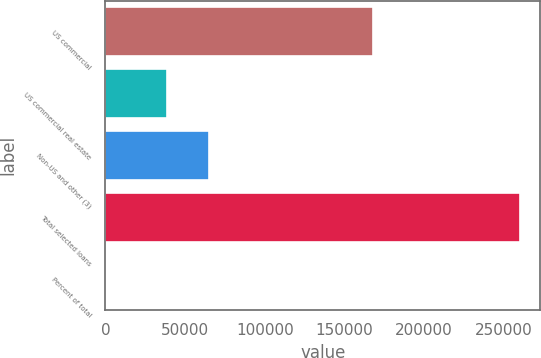<chart> <loc_0><loc_0><loc_500><loc_500><bar_chart><fcel>US commercial<fcel>US commercial real estate<fcel>Non-US and other (3)<fcel>Total selected loans<fcel>Percent of total<nl><fcel>167670<fcel>38826<fcel>64796.6<fcel>259766<fcel>60<nl></chart> 